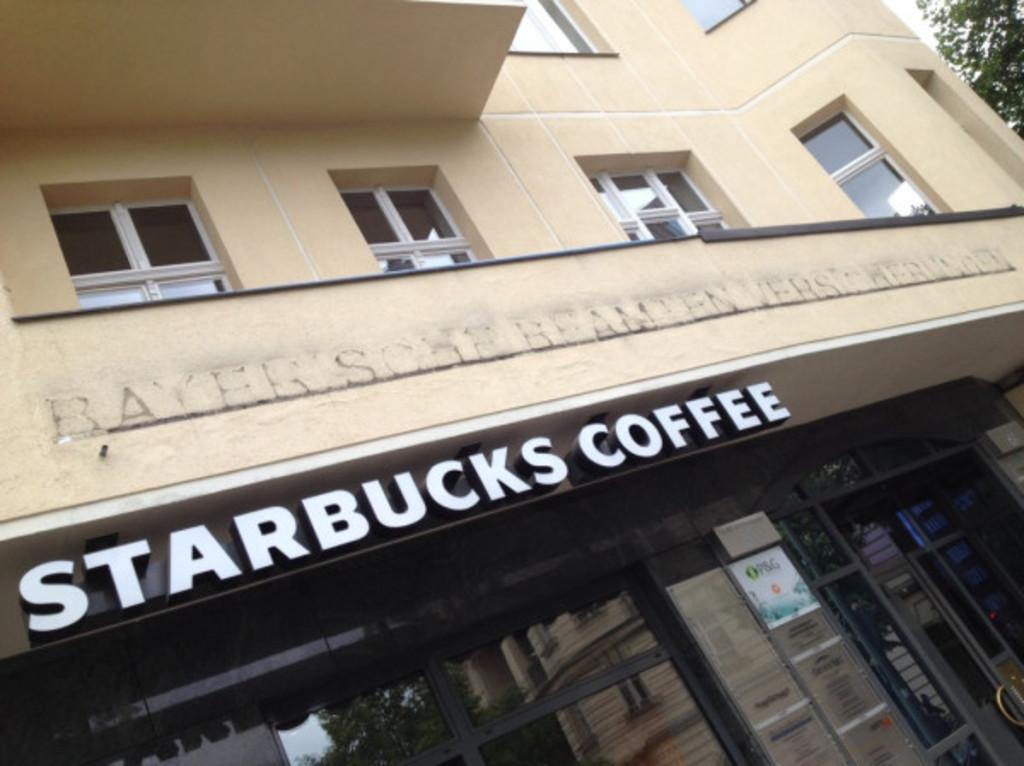In one or two sentences, can you explain what this image depicts? In this image there is a building on that there are windows, glasses, doors, posters and text. On the right there are trees and sky. 